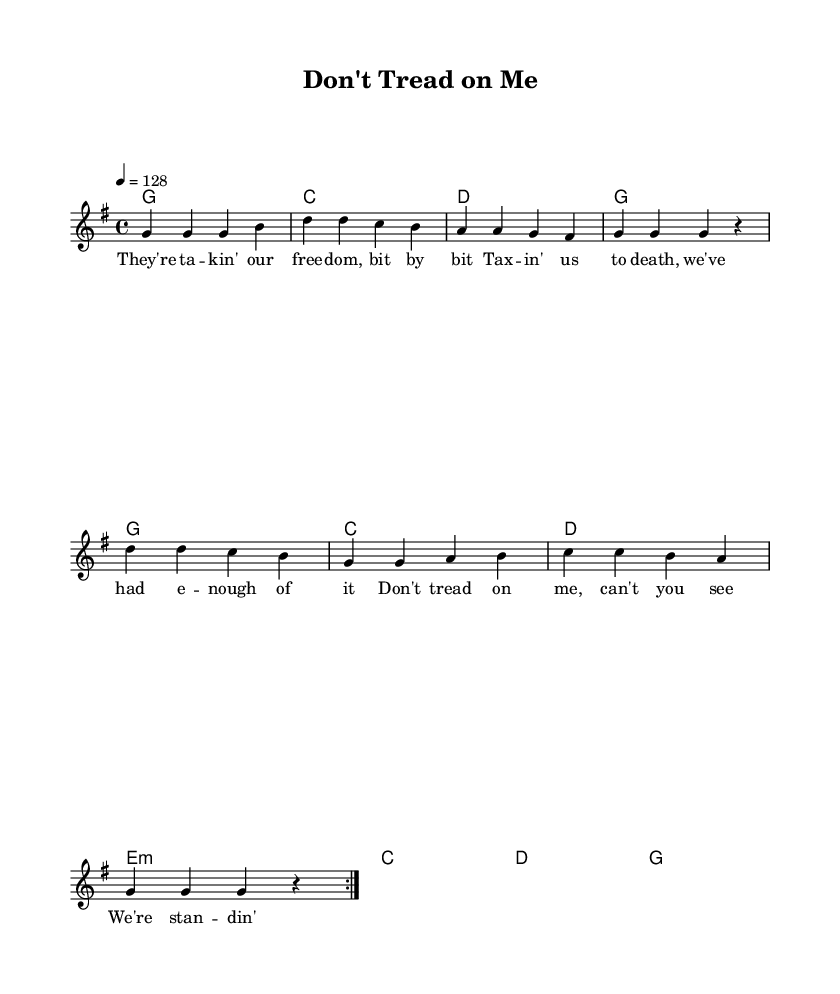What is the key signature of this music? The key signature is expressed by the absence of any sharps or flats, indicating that it is in G major.
Answer: G major What is the time signature of this piece? The time signature is indicated at the beginning of the score and it shows a regular pulse of four beats per measure. Therefore, it is 4/4.
Answer: 4/4 What is the tempo marking for this song? The tempo marking is written numerically as 128, indicating that there will be 128 beats per minute in the performance.
Answer: 128 How many times is the main melody repeated in the song structure? The repeat indication for the melody shows "volta 2," which means the melody will be played twice before moving on to the next section.
Answer: 2 What type of chord progression is predominantly used in this piece? Analyzing the section labeled with chord mode reveals that common country rock progressions are employed, specifically featuring I-IV-V movements.
Answer: I-IV-V What lyrical themes are present in this song? The lyrics suggest a strong message about freedom and resistance against government overreach and taxation, reflecting common themes in protest songs.
Answer: Freedom and resistance What is the structure of the song based on the parts indicated in the sheet music? The sheet music is structured with verses that are identified by repeated sections (indicated as volta), typical of a verse-chorus format common in country rock.
Answer: Verse-Chorus 